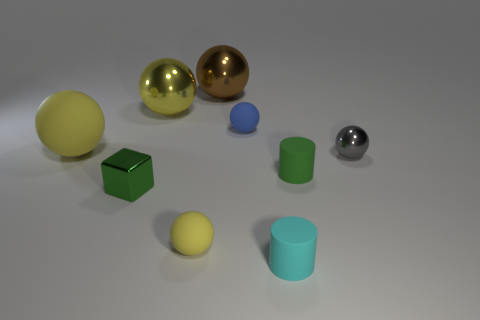Subtract all yellow spheres. How many were subtracted if there are1yellow spheres left? 2 Subtract all blue cylinders. How many yellow spheres are left? 3 Subtract all small blue balls. How many balls are left? 5 Subtract all brown balls. How many balls are left? 5 Subtract all cyan spheres. Subtract all red cubes. How many spheres are left? 6 Add 1 large shiny spheres. How many objects exist? 10 Subtract all balls. How many objects are left? 3 Add 2 large yellow metallic spheres. How many large yellow metallic spheres exist? 3 Subtract 1 cyan cylinders. How many objects are left? 8 Subtract all cyan objects. Subtract all small red rubber objects. How many objects are left? 8 